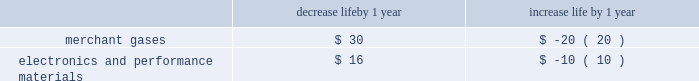The depreciable lives of production facilities within the merchant gases segment are principally 15 years .
Customer contracts associated with products produced at these types of facilities typically have a much shorter term .
The depreciable lives of production facilities within the electronics and performance materials segment , where there is not an associated long-term supply agreement , range from 10 to 15 years .
These depreciable lives have been determined based on historical experience combined with judgment on future assumptions such as technological advances , potential obsolescence , competitors 2019 actions , etc .
Management monitors its assumptions and may potentially need to adjust depreciable life as circumstances change .
A change in the depreciable life by one year for production facilities within the merchant gases and electronics and performance materials segments for which there is not an associated long-term customer supply agreement would impact annual depreciation expense as summarized below : decrease life by 1 year increase life by 1 year .
Impairment of assets plant and equipment plant and equipment held for use is grouped for impairment testing at the lowest level for which there are identifiable cash flows .
Impairment testing of the asset group occurs whenever events or changes in circumstances indicate that the carrying amount of the assets may not be recoverable .
Such circumstances would include a significant decrease in the market value of a long-lived asset grouping , a significant adverse change in the manner in which the asset grouping is being used or in its physical condition , a history of operating or cash flow losses associated with the use of the asset grouping , or changes in the expected useful life of the long-lived assets .
If such circumstances are determined to exist , an estimate of undiscounted future cash flows produced by that asset group is compared to the carrying value to determine whether impairment exists .
If an asset group is determined to be impaired , the loss is measured based on the difference between the asset group 2019s fair value and its carrying value .
An estimate of the asset group 2019s fair value is based on the discounted value of its estimated cash flows .
Assets to be disposed of by sale are reported at the lower of carrying amount or fair value less cost to sell .
The assumptions underlying cash flow projections represent management 2019s best estimates at the time of the impairment review .
Factors that management must estimate include industry and market conditions , sales volume and prices , costs to produce , inflation , etc .
Changes in key assumptions or actual conditions that differ from estimates could result in an impairment charge .
We use reasonable and supportable assumptions when performing impairment reviews and cannot predict the occurrence of future events and circumstances that could result in impairment charges .
Goodwill the acquisition method of accounting for business combinations currently requires us to make use of estimates and judgments to allocate the purchase price paid for acquisitions to the fair value of the net tangible and identifiable intangible assets .
Goodwill represents the excess of the aggregate purchase price over the fair value of net assets of an acquired entity .
Goodwill , including goodwill associated with equity affiliates of $ 126.4 , was $ 1780.2 as of 30 september 2013 .
The majority of our goodwill is assigned to reporting units within the merchant gases and electronics and performance materials segments .
Goodwill increased in 2013 , primarily as a result of the epco and wcg acquisitions in merchant gases during the third quarter .
Disclosures related to goodwill are included in note 10 , goodwill , to the consolidated financial statements .
We perform an impairment test annually in the fourth quarter of the fiscal year .
In addition , goodwill would be tested more frequently if changes in circumstances or the occurrence of events indicated that potential impairment exists .
The tests are done at the reporting unit level , which is defined as one level below the operating segment for which discrete financial information is available and whose operating results are reviewed by segment managers regularly .
Currently , we have four business segments and thirteen reporting units .
Reporting units are primarily based on products and geographic locations within each business segment .
As part of the goodwill impairment testing , and as permitted under the accounting guidance , we have the option to first assess qualitative factors to determine whether it is more likely than not that the fair value of a reporting unit is less than its carrying value .
If we choose not to complete a qualitative assessment for a given reporting unit , or if the .
What is the depreciation expense with the production facilities within the merchant gases segment accumulated in 15 years? 
Rationale: it is the number of years expected in its depreciable life multiplied by the increased life by a 1-year value .
Computations: (15 * 20)
Answer: 300.0. 